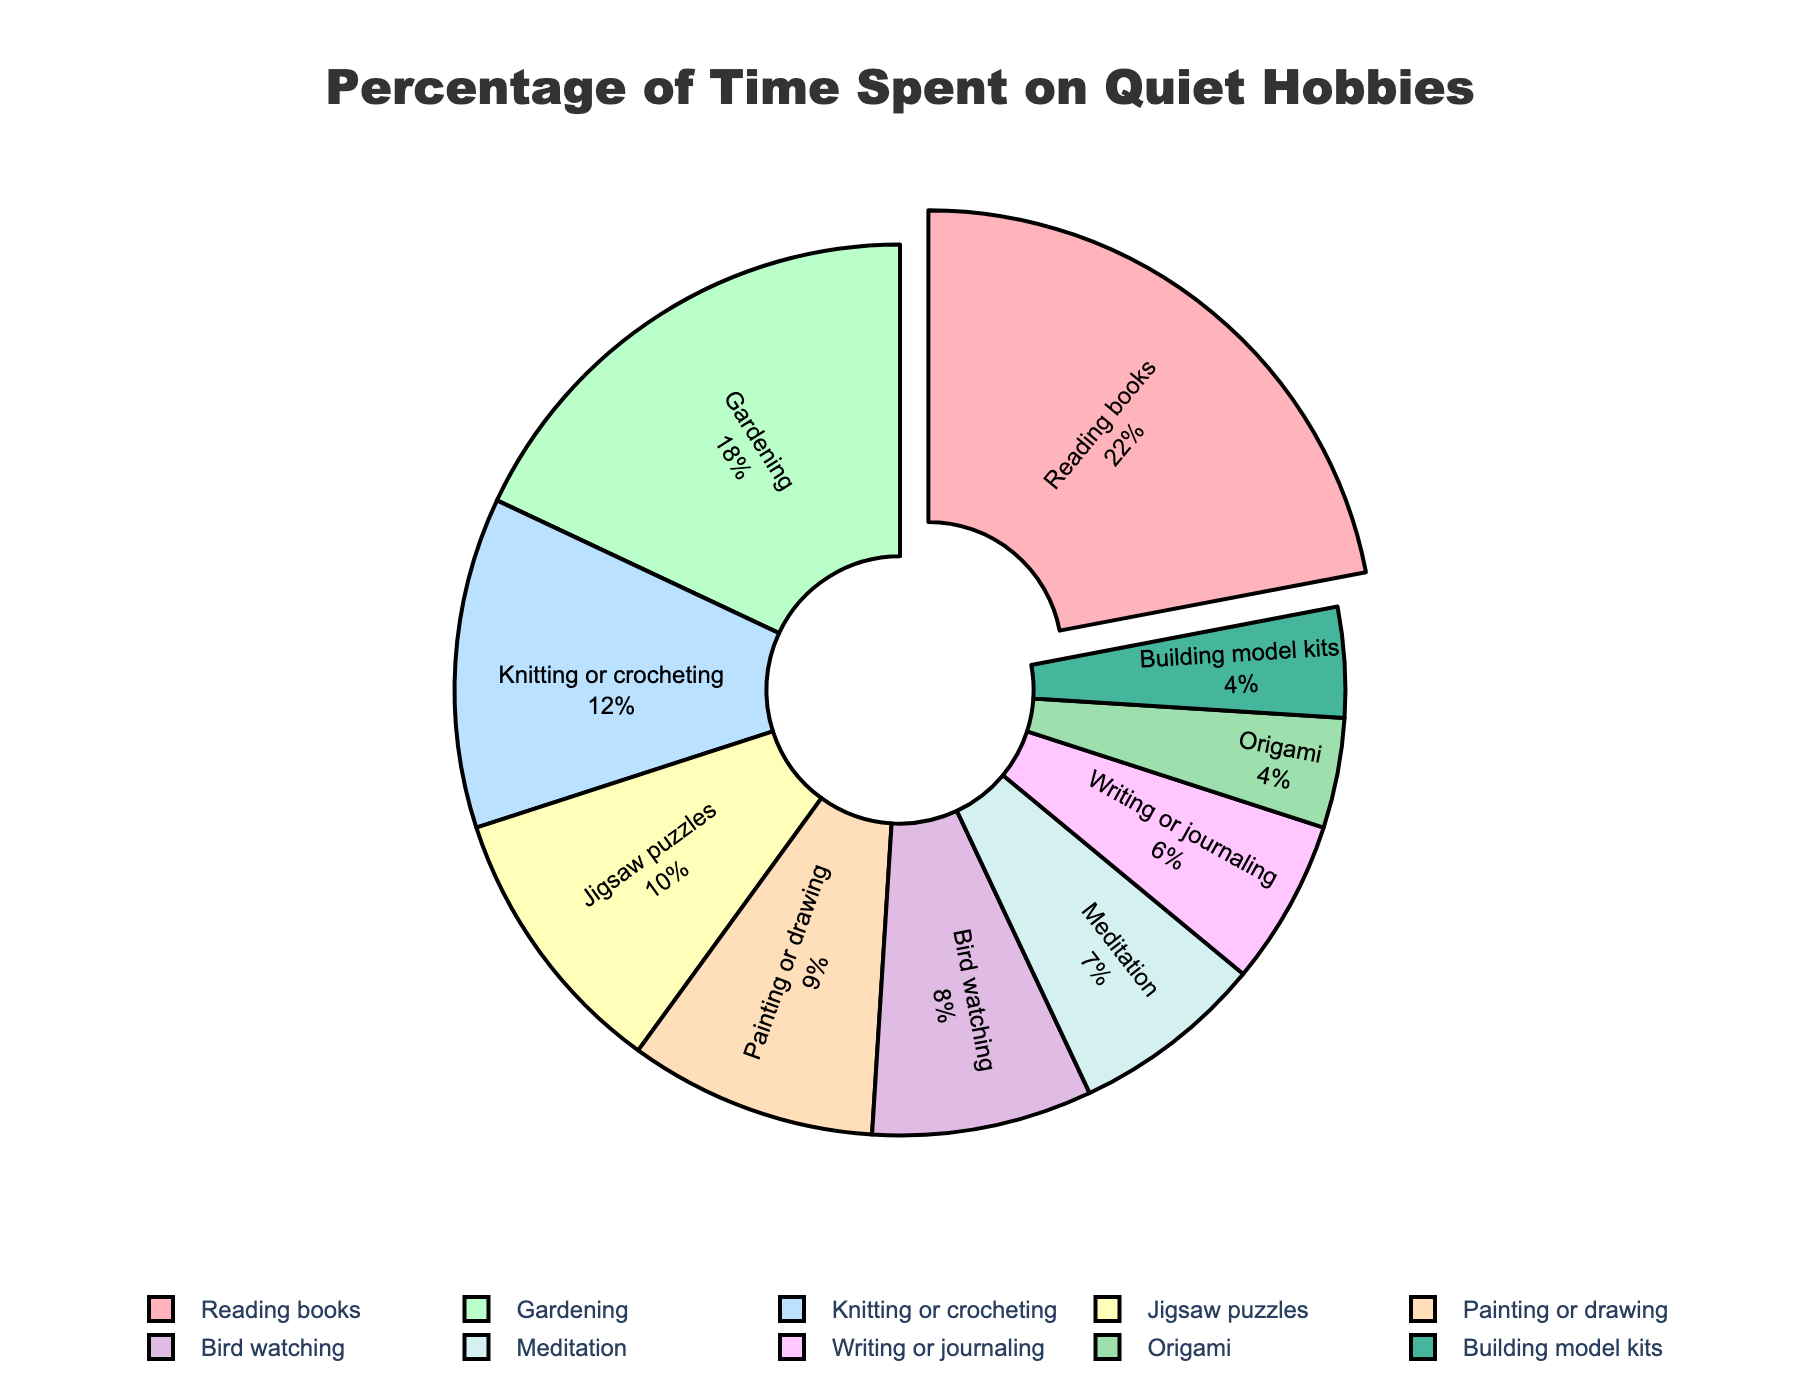What's the most popular quiet hobby among adults? The most popular hobby is the one with the largest percentage. According to the figure, reading books has the highest percentage of 22%.
Answer: Reading books Which two hobbies have the smallest percentage of time spent? The hobbies with the smallest percentages are the ones with the lowest numbers. Origami and building model kits each have 4%.
Answer: Origami and building model kits What is the total percentage of time spent on Painting or drawing, Writing or journaling, and Knitting or crocheting? Add the percentages of "Painting or drawing" (9%), "Writing or journaling" (6%), and "Knitting or crocheting" (12%). The total is 9 + 6 + 12 = 27%.
Answer: 27% How much more time is spent on gardening compared to bird watching? Subtract the percentage for bird watching (8%) from the percentage for gardening (18%). The difference is 18 - 8 = 10%.
Answer: 10% Of the hobbies listed, which one is the least common but still more popular than origami and building model kits? Identify the hobbies with the smallest percentages greater than 4% (the percentage for origami and building model kits). Writing or journaling has 6%, which is the next smallest percentage.
Answer: Writing or journaling Which hobby occupies a middle position in terms of percentage of time spent? Identify the hobby at the median value. Arranged in order, the percentages are 4, 4, 6, 7, 8, 9, 10, 12, 18, 22. The middle values are 8 (bird watching) and 9 (painting or drawing). The median is between bird watching and painting or drawing.
Answer: Bird watching and painting or drawing What is the combined percentage of time spent on the top three most popular hobbies? Add the percentages for the top three hobbies: reading books (22%), gardening (18%), and knitting or crocheting (12%). The total is 22 + 18 + 12 = 52%.
Answer: 52% What is the difference in percentage between reading books and meditation? Subtract the percentage for meditation (7%) from the percentage for reading books (22%). The difference is 22 - 7 = 15%.
Answer: 15% Which visual attribute highlights the most popular hobby in the pie chart? The most popular hobby, reading books (22%), is highlighted by being slightly pulled out from the rest of the chart.
Answer: Pulled out from the chart What is the percentage of time spent on hobbies that involve creating something (Knitting or crocheting, Painting or drawing, Origami, Building model kits)? Add the percentages for "Knitting or crocheting" (12%), "Painting or drawing" (9%), "Origami" (4%), and "Building model kits" (4%). The total is 12 + 9 + 4 + 4 = 29%.
Answer: 29% 